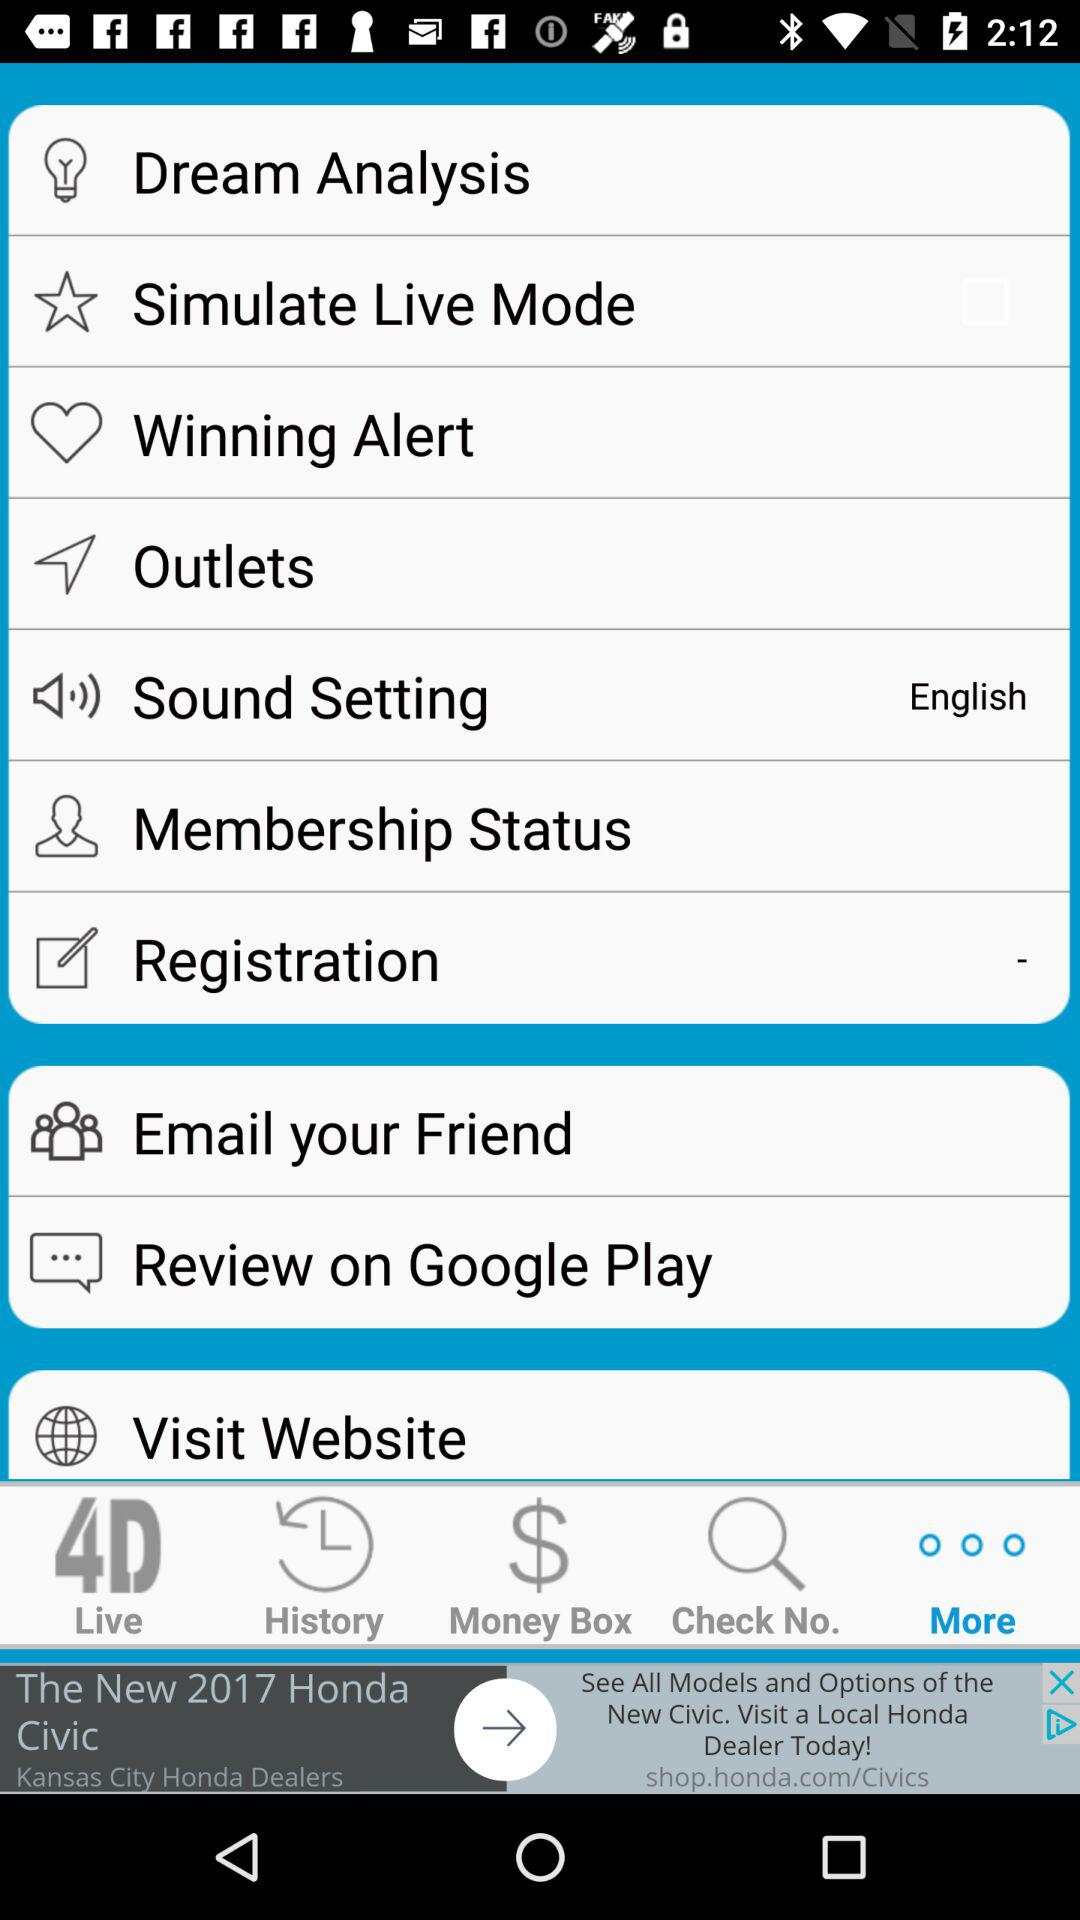What language is selected in "Sound Setting"? The selected language in "Sound Setting" is English. 